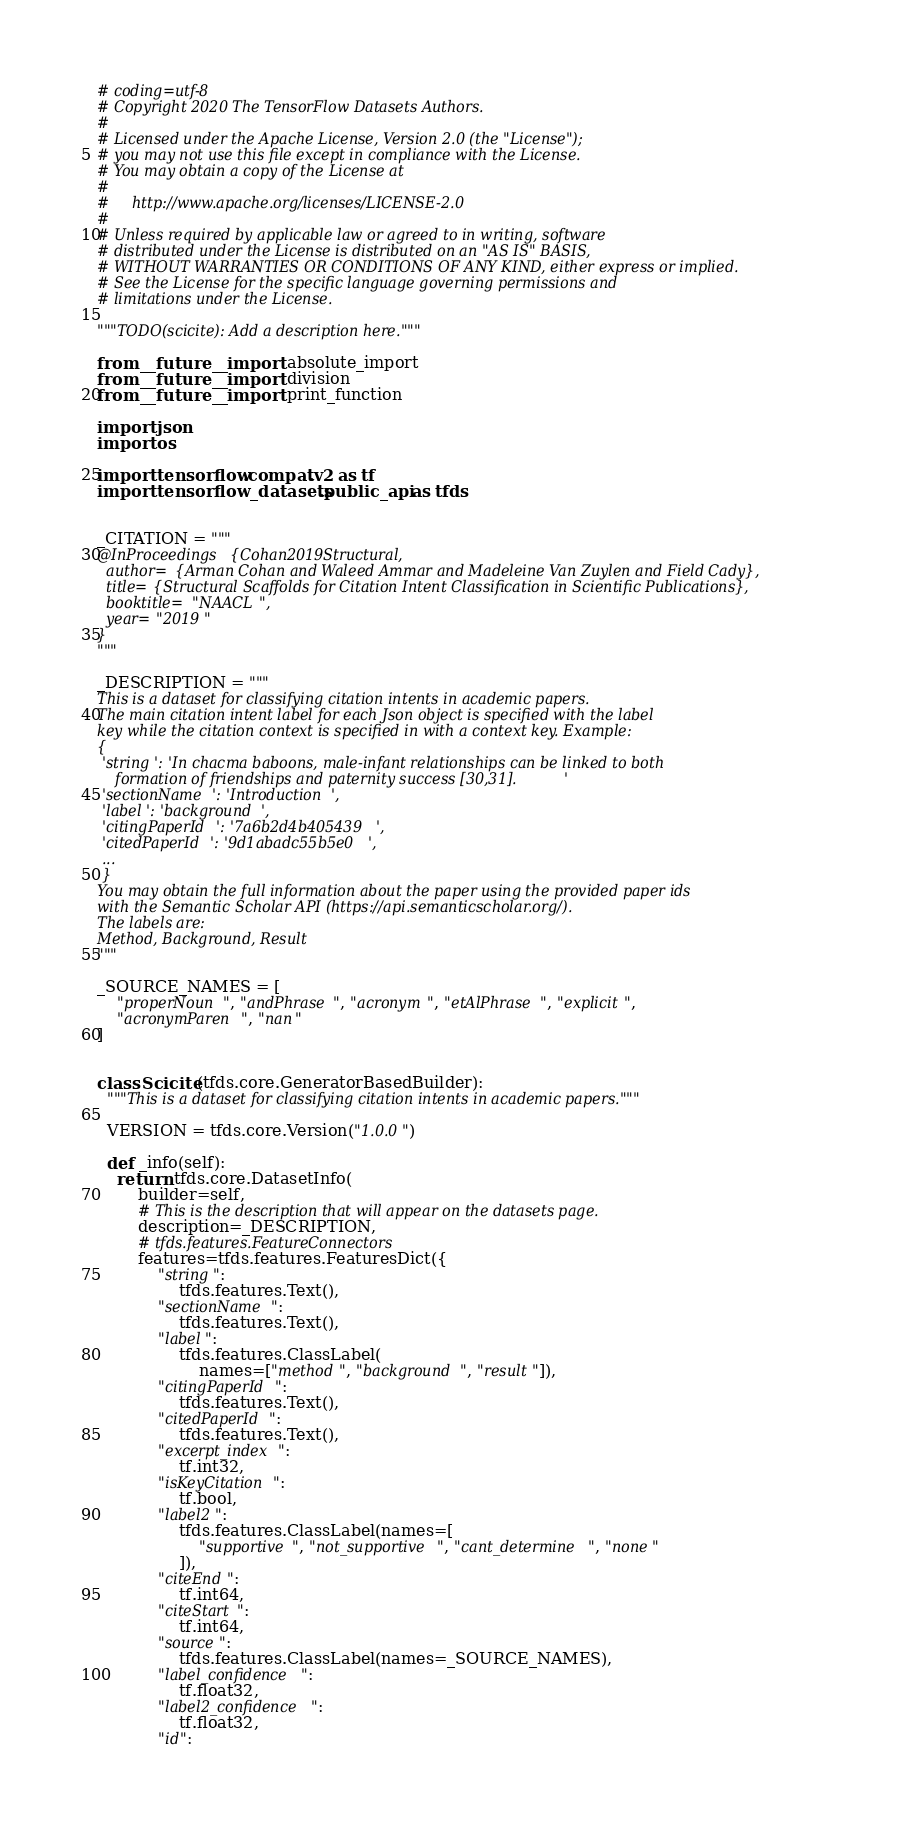<code> <loc_0><loc_0><loc_500><loc_500><_Python_># coding=utf-8
# Copyright 2020 The TensorFlow Datasets Authors.
#
# Licensed under the Apache License, Version 2.0 (the "License");
# you may not use this file except in compliance with the License.
# You may obtain a copy of the License at
#
#     http://www.apache.org/licenses/LICENSE-2.0
#
# Unless required by applicable law or agreed to in writing, software
# distributed under the License is distributed on an "AS IS" BASIS,
# WITHOUT WARRANTIES OR CONDITIONS OF ANY KIND, either express or implied.
# See the License for the specific language governing permissions and
# limitations under the License.

"""TODO(scicite): Add a description here."""

from __future__ import absolute_import
from __future__ import division
from __future__ import print_function

import json
import os

import tensorflow.compat.v2 as tf
import tensorflow_datasets.public_api as tfds


_CITATION = """
@InProceedings{Cohan2019Structural,
  author={Arman Cohan and Waleed Ammar and Madeleine Van Zuylen and Field Cady},
  title={Structural Scaffolds for Citation Intent Classification in Scientific Publications},
  booktitle="NAACL",
  year="2019"
}
"""

_DESCRIPTION = """
This is a dataset for classifying citation intents in academic papers.
The main citation intent label for each Json object is specified with the label
key while the citation context is specified in with a context key. Example:
{
 'string': 'In chacma baboons, male-infant relationships can be linked to both
    formation of friendships and paternity success [30,31].'
 'sectionName': 'Introduction',
 'label': 'background',
 'citingPaperId': '7a6b2d4b405439',
 'citedPaperId': '9d1abadc55b5e0',
 ...
 }
You may obtain the full information about the paper using the provided paper ids
with the Semantic Scholar API (https://api.semanticscholar.org/).
The labels are:
Method, Background, Result
"""

_SOURCE_NAMES = [
    "properNoun", "andPhrase", "acronym", "etAlPhrase", "explicit",
    "acronymParen", "nan"
]


class Scicite(tfds.core.GeneratorBasedBuilder):
  """This is a dataset for classifying citation intents in academic papers."""

  VERSION = tfds.core.Version("1.0.0")

  def _info(self):
    return tfds.core.DatasetInfo(
        builder=self,
        # This is the description that will appear on the datasets page.
        description=_DESCRIPTION,
        # tfds.features.FeatureConnectors
        features=tfds.features.FeaturesDict({
            "string":
                tfds.features.Text(),
            "sectionName":
                tfds.features.Text(),
            "label":
                tfds.features.ClassLabel(
                    names=["method", "background", "result"]),
            "citingPaperId":
                tfds.features.Text(),
            "citedPaperId":
                tfds.features.Text(),
            "excerpt_index":
                tf.int32,
            "isKeyCitation":
                tf.bool,
            "label2":
                tfds.features.ClassLabel(names=[
                    "supportive", "not_supportive", "cant_determine", "none"
                ]),
            "citeEnd":
                tf.int64,
            "citeStart":
                tf.int64,
            "source":
                tfds.features.ClassLabel(names=_SOURCE_NAMES),
            "label_confidence":
                tf.float32,
            "label2_confidence":
                tf.float32,
            "id":</code> 